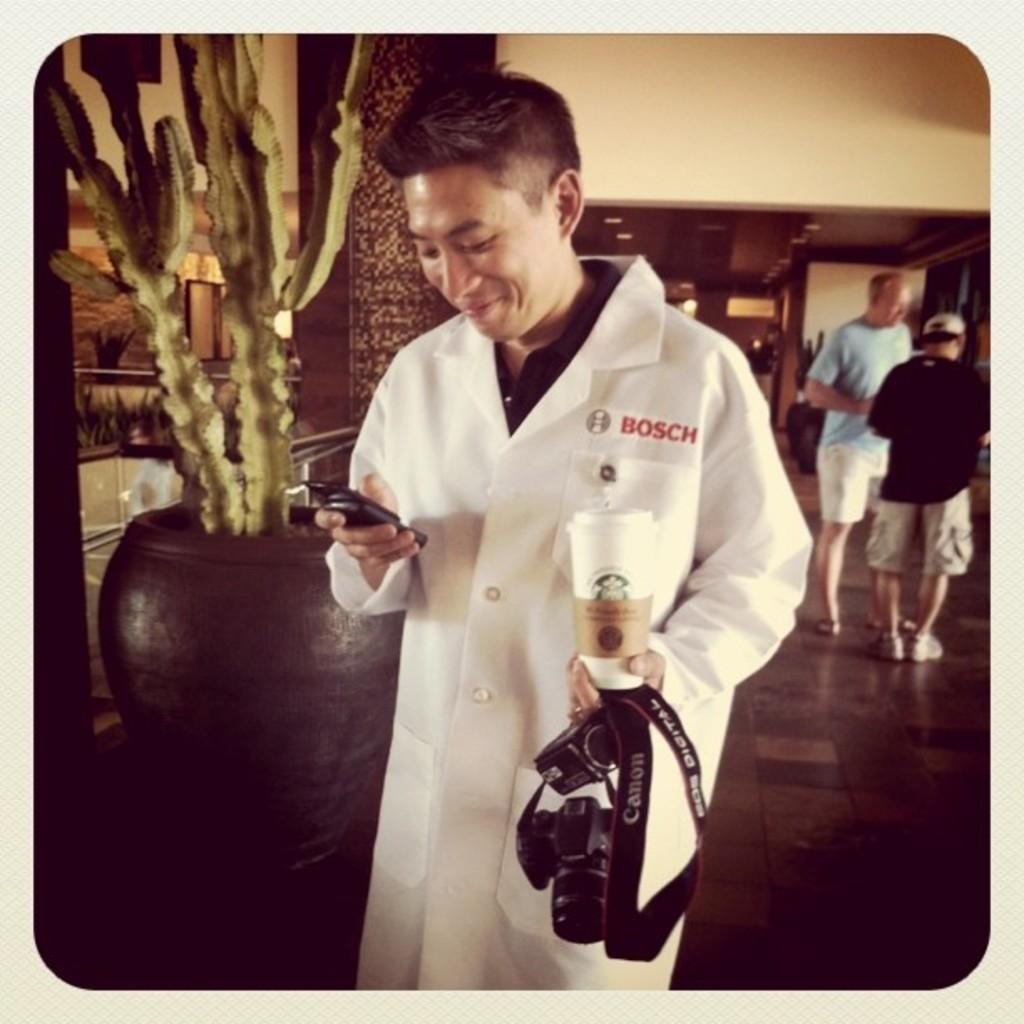What is the person in the image holding in their hand? The person is holding a glass in the image. What else is the person holding in the image? The person is holding a bell with a camera and a mobile. What is the expression on the person's face? The person is smiling in the image. What can be seen in the background of the image? There are plants, a pot, walls, lights, and people in the background of the image. What is the surface visible in the image? There is a floor visible in the image. How many chairs are visible in the image? There are no chairs visible in the image. What type of competition is taking place in the image? There is no competition present in the image. 